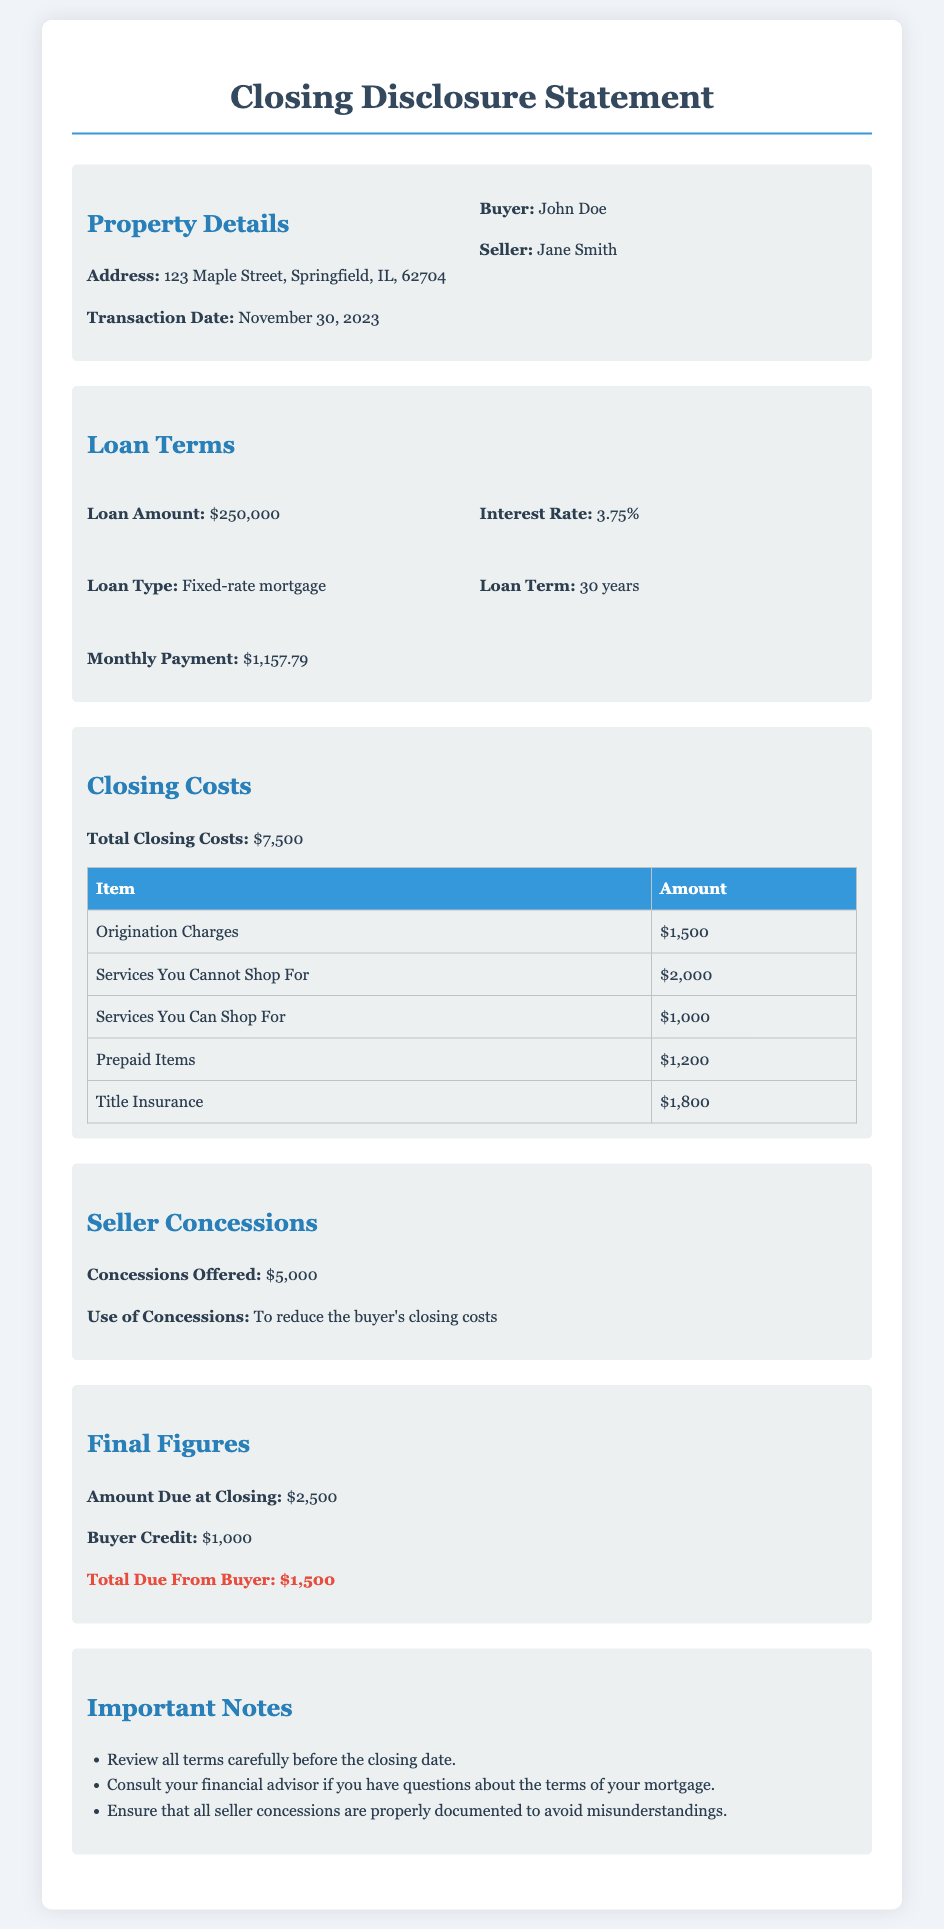what is the address of the property? The address of the property is listed in the document under the Property Details section.
Answer: 123 Maple Street, Springfield, IL, 62704 what is the total closing costs? The total closing costs can be found in the Closing Costs section of the document.
Answer: $7,500 who is the buyer? The buyer's name is mentioned in the Property Details section.
Answer: John Doe what is the loan amount? The loan amount is specified in the Loan Terms section of the document.
Answer: $250,000 how much are the seller concessions? The seller concessions are listed in the Seller Concessions section.
Answer: $5,000 what is the monthly payment? The monthly payment can be found in the Loan Terms section of the document.
Answer: $1,157.79 what is the amount due at closing? The amount due at closing is specified in the Final Figures section.
Answer: $2,500 how much is the buyer credit? The buyer credit is detailed in the Final Figures section of the document.
Answer: $1,000 what is the total due from the buyer? The total due from the buyer is highlighted in the Final Figures section of the document.
Answer: $1,500 